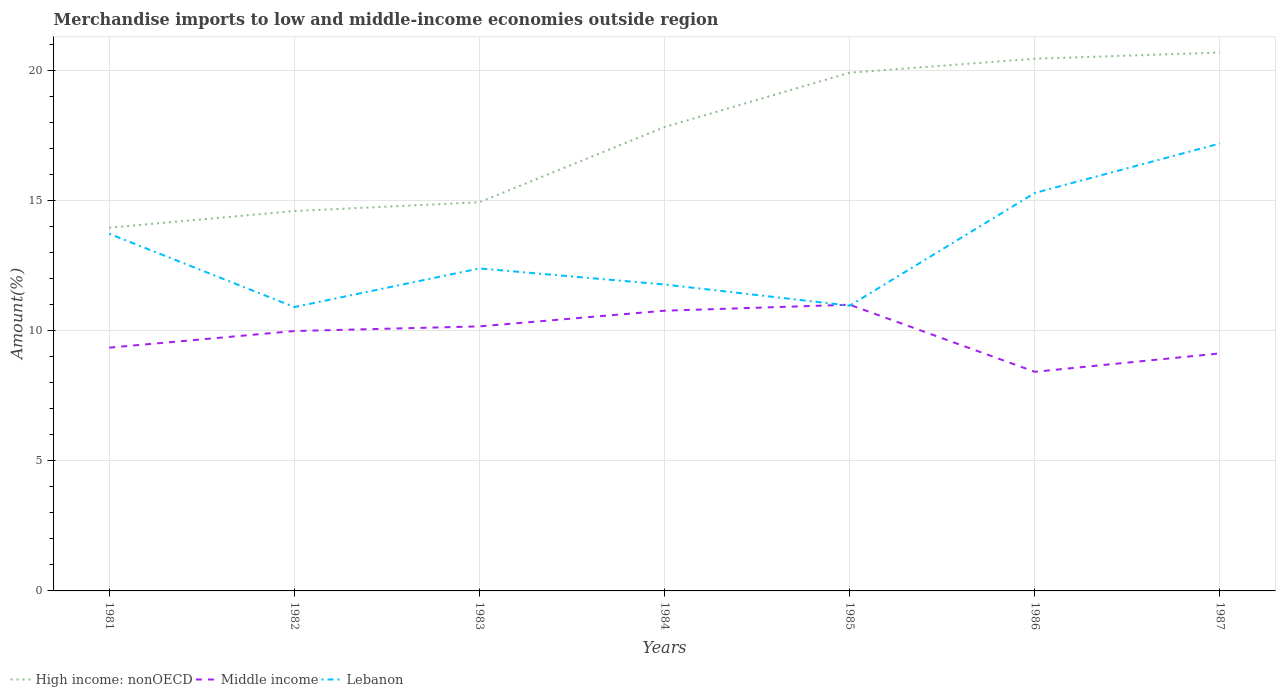Across all years, what is the maximum percentage of amount earned from merchandise imports in Lebanon?
Give a very brief answer. 10.9. In which year was the percentage of amount earned from merchandise imports in Middle income maximum?
Give a very brief answer. 1986. What is the total percentage of amount earned from merchandise imports in Middle income in the graph?
Make the answer very short. 0.86. What is the difference between the highest and the second highest percentage of amount earned from merchandise imports in Lebanon?
Provide a succinct answer. 6.28. How many lines are there?
Your response must be concise. 3. Does the graph contain any zero values?
Provide a short and direct response. No. What is the title of the graph?
Provide a short and direct response. Merchandise imports to low and middle-income economies outside region. What is the label or title of the Y-axis?
Offer a terse response. Amount(%). What is the Amount(%) of High income: nonOECD in 1981?
Offer a very short reply. 13.95. What is the Amount(%) in Middle income in 1981?
Provide a short and direct response. 9.34. What is the Amount(%) of Lebanon in 1981?
Your answer should be compact. 13.71. What is the Amount(%) of High income: nonOECD in 1982?
Your answer should be compact. 14.59. What is the Amount(%) of Middle income in 1982?
Your answer should be compact. 9.98. What is the Amount(%) of Lebanon in 1982?
Keep it short and to the point. 10.9. What is the Amount(%) of High income: nonOECD in 1983?
Offer a terse response. 14.93. What is the Amount(%) in Middle income in 1983?
Your answer should be compact. 10.16. What is the Amount(%) in Lebanon in 1983?
Offer a terse response. 12.38. What is the Amount(%) of High income: nonOECD in 1984?
Offer a terse response. 17.81. What is the Amount(%) of Middle income in 1984?
Ensure brevity in your answer.  10.76. What is the Amount(%) of Lebanon in 1984?
Your answer should be compact. 11.77. What is the Amount(%) in High income: nonOECD in 1985?
Provide a succinct answer. 19.9. What is the Amount(%) in Middle income in 1985?
Give a very brief answer. 10.99. What is the Amount(%) of Lebanon in 1985?
Provide a succinct answer. 10.96. What is the Amount(%) of High income: nonOECD in 1986?
Ensure brevity in your answer.  20.44. What is the Amount(%) in Middle income in 1986?
Your answer should be very brief. 8.41. What is the Amount(%) of Lebanon in 1986?
Provide a succinct answer. 15.28. What is the Amount(%) in High income: nonOECD in 1987?
Your response must be concise. 20.68. What is the Amount(%) in Middle income in 1987?
Offer a terse response. 9.12. What is the Amount(%) of Lebanon in 1987?
Offer a terse response. 17.18. Across all years, what is the maximum Amount(%) of High income: nonOECD?
Your answer should be compact. 20.68. Across all years, what is the maximum Amount(%) of Middle income?
Your answer should be very brief. 10.99. Across all years, what is the maximum Amount(%) in Lebanon?
Offer a terse response. 17.18. Across all years, what is the minimum Amount(%) of High income: nonOECD?
Offer a very short reply. 13.95. Across all years, what is the minimum Amount(%) in Middle income?
Your answer should be compact. 8.41. Across all years, what is the minimum Amount(%) in Lebanon?
Keep it short and to the point. 10.9. What is the total Amount(%) in High income: nonOECD in the graph?
Provide a succinct answer. 122.29. What is the total Amount(%) in Middle income in the graph?
Keep it short and to the point. 68.77. What is the total Amount(%) in Lebanon in the graph?
Your answer should be very brief. 92.19. What is the difference between the Amount(%) of High income: nonOECD in 1981 and that in 1982?
Make the answer very short. -0.64. What is the difference between the Amount(%) of Middle income in 1981 and that in 1982?
Offer a very short reply. -0.64. What is the difference between the Amount(%) of Lebanon in 1981 and that in 1982?
Keep it short and to the point. 2.81. What is the difference between the Amount(%) of High income: nonOECD in 1981 and that in 1983?
Make the answer very short. -0.98. What is the difference between the Amount(%) of Middle income in 1981 and that in 1983?
Your answer should be very brief. -0.82. What is the difference between the Amount(%) in Lebanon in 1981 and that in 1983?
Your response must be concise. 1.33. What is the difference between the Amount(%) in High income: nonOECD in 1981 and that in 1984?
Offer a terse response. -3.86. What is the difference between the Amount(%) of Middle income in 1981 and that in 1984?
Your response must be concise. -1.42. What is the difference between the Amount(%) of Lebanon in 1981 and that in 1984?
Keep it short and to the point. 1.95. What is the difference between the Amount(%) of High income: nonOECD in 1981 and that in 1985?
Provide a short and direct response. -5.95. What is the difference between the Amount(%) in Middle income in 1981 and that in 1985?
Keep it short and to the point. -1.65. What is the difference between the Amount(%) of Lebanon in 1981 and that in 1985?
Give a very brief answer. 2.76. What is the difference between the Amount(%) in High income: nonOECD in 1981 and that in 1986?
Your answer should be very brief. -6.49. What is the difference between the Amount(%) in Middle income in 1981 and that in 1986?
Offer a terse response. 0.93. What is the difference between the Amount(%) of Lebanon in 1981 and that in 1986?
Make the answer very short. -1.57. What is the difference between the Amount(%) of High income: nonOECD in 1981 and that in 1987?
Your answer should be compact. -6.73. What is the difference between the Amount(%) of Middle income in 1981 and that in 1987?
Your response must be concise. 0.22. What is the difference between the Amount(%) in Lebanon in 1981 and that in 1987?
Provide a succinct answer. -3.47. What is the difference between the Amount(%) of High income: nonOECD in 1982 and that in 1983?
Offer a terse response. -0.34. What is the difference between the Amount(%) of Middle income in 1982 and that in 1983?
Offer a terse response. -0.18. What is the difference between the Amount(%) in Lebanon in 1982 and that in 1983?
Provide a succinct answer. -1.48. What is the difference between the Amount(%) in High income: nonOECD in 1982 and that in 1984?
Offer a terse response. -3.23. What is the difference between the Amount(%) in Middle income in 1982 and that in 1984?
Provide a short and direct response. -0.78. What is the difference between the Amount(%) of Lebanon in 1982 and that in 1984?
Your answer should be compact. -0.87. What is the difference between the Amount(%) of High income: nonOECD in 1982 and that in 1985?
Provide a short and direct response. -5.31. What is the difference between the Amount(%) of Middle income in 1982 and that in 1985?
Provide a short and direct response. -1.01. What is the difference between the Amount(%) in Lebanon in 1982 and that in 1985?
Your answer should be compact. -0.05. What is the difference between the Amount(%) of High income: nonOECD in 1982 and that in 1986?
Ensure brevity in your answer.  -5.85. What is the difference between the Amount(%) in Middle income in 1982 and that in 1986?
Keep it short and to the point. 1.57. What is the difference between the Amount(%) in Lebanon in 1982 and that in 1986?
Offer a terse response. -4.38. What is the difference between the Amount(%) of High income: nonOECD in 1982 and that in 1987?
Offer a terse response. -6.09. What is the difference between the Amount(%) in Middle income in 1982 and that in 1987?
Your answer should be compact. 0.86. What is the difference between the Amount(%) of Lebanon in 1982 and that in 1987?
Ensure brevity in your answer.  -6.28. What is the difference between the Amount(%) in High income: nonOECD in 1983 and that in 1984?
Give a very brief answer. -2.89. What is the difference between the Amount(%) in Middle income in 1983 and that in 1984?
Provide a short and direct response. -0.6. What is the difference between the Amount(%) in Lebanon in 1983 and that in 1984?
Ensure brevity in your answer.  0.62. What is the difference between the Amount(%) of High income: nonOECD in 1983 and that in 1985?
Keep it short and to the point. -4.97. What is the difference between the Amount(%) in Middle income in 1983 and that in 1985?
Your answer should be very brief. -0.83. What is the difference between the Amount(%) of Lebanon in 1983 and that in 1985?
Give a very brief answer. 1.43. What is the difference between the Amount(%) in High income: nonOECD in 1983 and that in 1986?
Offer a terse response. -5.51. What is the difference between the Amount(%) of Middle income in 1983 and that in 1986?
Your answer should be compact. 1.74. What is the difference between the Amount(%) of Lebanon in 1983 and that in 1986?
Provide a succinct answer. -2.9. What is the difference between the Amount(%) of High income: nonOECD in 1983 and that in 1987?
Offer a terse response. -5.75. What is the difference between the Amount(%) in Middle income in 1983 and that in 1987?
Make the answer very short. 1.04. What is the difference between the Amount(%) of Lebanon in 1983 and that in 1987?
Provide a short and direct response. -4.8. What is the difference between the Amount(%) of High income: nonOECD in 1984 and that in 1985?
Give a very brief answer. -2.09. What is the difference between the Amount(%) of Middle income in 1984 and that in 1985?
Your answer should be compact. -0.23. What is the difference between the Amount(%) in Lebanon in 1984 and that in 1985?
Your answer should be very brief. 0.81. What is the difference between the Amount(%) in High income: nonOECD in 1984 and that in 1986?
Ensure brevity in your answer.  -2.62. What is the difference between the Amount(%) in Middle income in 1984 and that in 1986?
Ensure brevity in your answer.  2.35. What is the difference between the Amount(%) in Lebanon in 1984 and that in 1986?
Give a very brief answer. -3.52. What is the difference between the Amount(%) of High income: nonOECD in 1984 and that in 1987?
Keep it short and to the point. -2.86. What is the difference between the Amount(%) in Middle income in 1984 and that in 1987?
Offer a terse response. 1.64. What is the difference between the Amount(%) of Lebanon in 1984 and that in 1987?
Offer a terse response. -5.42. What is the difference between the Amount(%) of High income: nonOECD in 1985 and that in 1986?
Offer a terse response. -0.54. What is the difference between the Amount(%) of Middle income in 1985 and that in 1986?
Your answer should be very brief. 2.58. What is the difference between the Amount(%) of Lebanon in 1985 and that in 1986?
Provide a succinct answer. -4.33. What is the difference between the Amount(%) in High income: nonOECD in 1985 and that in 1987?
Provide a short and direct response. -0.77. What is the difference between the Amount(%) of Middle income in 1985 and that in 1987?
Your answer should be very brief. 1.87. What is the difference between the Amount(%) of Lebanon in 1985 and that in 1987?
Offer a very short reply. -6.23. What is the difference between the Amount(%) in High income: nonOECD in 1986 and that in 1987?
Your response must be concise. -0.24. What is the difference between the Amount(%) of Middle income in 1986 and that in 1987?
Your response must be concise. -0.71. What is the difference between the Amount(%) of Lebanon in 1986 and that in 1987?
Your answer should be compact. -1.9. What is the difference between the Amount(%) in High income: nonOECD in 1981 and the Amount(%) in Middle income in 1982?
Offer a very short reply. 3.97. What is the difference between the Amount(%) of High income: nonOECD in 1981 and the Amount(%) of Lebanon in 1982?
Your answer should be compact. 3.05. What is the difference between the Amount(%) in Middle income in 1981 and the Amount(%) in Lebanon in 1982?
Give a very brief answer. -1.56. What is the difference between the Amount(%) of High income: nonOECD in 1981 and the Amount(%) of Middle income in 1983?
Offer a terse response. 3.79. What is the difference between the Amount(%) in High income: nonOECD in 1981 and the Amount(%) in Lebanon in 1983?
Offer a terse response. 1.57. What is the difference between the Amount(%) of Middle income in 1981 and the Amount(%) of Lebanon in 1983?
Your answer should be compact. -3.04. What is the difference between the Amount(%) of High income: nonOECD in 1981 and the Amount(%) of Middle income in 1984?
Give a very brief answer. 3.19. What is the difference between the Amount(%) in High income: nonOECD in 1981 and the Amount(%) in Lebanon in 1984?
Keep it short and to the point. 2.18. What is the difference between the Amount(%) of Middle income in 1981 and the Amount(%) of Lebanon in 1984?
Give a very brief answer. -2.43. What is the difference between the Amount(%) of High income: nonOECD in 1981 and the Amount(%) of Middle income in 1985?
Offer a very short reply. 2.96. What is the difference between the Amount(%) in High income: nonOECD in 1981 and the Amount(%) in Lebanon in 1985?
Provide a succinct answer. 2.99. What is the difference between the Amount(%) of Middle income in 1981 and the Amount(%) of Lebanon in 1985?
Offer a terse response. -1.61. What is the difference between the Amount(%) in High income: nonOECD in 1981 and the Amount(%) in Middle income in 1986?
Your response must be concise. 5.53. What is the difference between the Amount(%) of High income: nonOECD in 1981 and the Amount(%) of Lebanon in 1986?
Provide a short and direct response. -1.33. What is the difference between the Amount(%) in Middle income in 1981 and the Amount(%) in Lebanon in 1986?
Make the answer very short. -5.94. What is the difference between the Amount(%) in High income: nonOECD in 1981 and the Amount(%) in Middle income in 1987?
Ensure brevity in your answer.  4.83. What is the difference between the Amount(%) in High income: nonOECD in 1981 and the Amount(%) in Lebanon in 1987?
Offer a very short reply. -3.23. What is the difference between the Amount(%) in Middle income in 1981 and the Amount(%) in Lebanon in 1987?
Make the answer very short. -7.84. What is the difference between the Amount(%) in High income: nonOECD in 1982 and the Amount(%) in Middle income in 1983?
Your answer should be very brief. 4.43. What is the difference between the Amount(%) in High income: nonOECD in 1982 and the Amount(%) in Lebanon in 1983?
Offer a terse response. 2.2. What is the difference between the Amount(%) in Middle income in 1982 and the Amount(%) in Lebanon in 1983?
Your answer should be compact. -2.4. What is the difference between the Amount(%) of High income: nonOECD in 1982 and the Amount(%) of Middle income in 1984?
Provide a succinct answer. 3.83. What is the difference between the Amount(%) in High income: nonOECD in 1982 and the Amount(%) in Lebanon in 1984?
Offer a terse response. 2.82. What is the difference between the Amount(%) in Middle income in 1982 and the Amount(%) in Lebanon in 1984?
Offer a terse response. -1.79. What is the difference between the Amount(%) in High income: nonOECD in 1982 and the Amount(%) in Middle income in 1985?
Offer a very short reply. 3.6. What is the difference between the Amount(%) of High income: nonOECD in 1982 and the Amount(%) of Lebanon in 1985?
Give a very brief answer. 3.63. What is the difference between the Amount(%) of Middle income in 1982 and the Amount(%) of Lebanon in 1985?
Your response must be concise. -0.97. What is the difference between the Amount(%) of High income: nonOECD in 1982 and the Amount(%) of Middle income in 1986?
Keep it short and to the point. 6.17. What is the difference between the Amount(%) in High income: nonOECD in 1982 and the Amount(%) in Lebanon in 1986?
Your response must be concise. -0.69. What is the difference between the Amount(%) in Middle income in 1982 and the Amount(%) in Lebanon in 1986?
Keep it short and to the point. -5.3. What is the difference between the Amount(%) in High income: nonOECD in 1982 and the Amount(%) in Middle income in 1987?
Your answer should be very brief. 5.47. What is the difference between the Amount(%) of High income: nonOECD in 1982 and the Amount(%) of Lebanon in 1987?
Offer a very short reply. -2.59. What is the difference between the Amount(%) in Middle income in 1982 and the Amount(%) in Lebanon in 1987?
Your answer should be very brief. -7.2. What is the difference between the Amount(%) in High income: nonOECD in 1983 and the Amount(%) in Middle income in 1984?
Offer a terse response. 4.17. What is the difference between the Amount(%) of High income: nonOECD in 1983 and the Amount(%) of Lebanon in 1984?
Offer a very short reply. 3.16. What is the difference between the Amount(%) of Middle income in 1983 and the Amount(%) of Lebanon in 1984?
Make the answer very short. -1.61. What is the difference between the Amount(%) of High income: nonOECD in 1983 and the Amount(%) of Middle income in 1985?
Make the answer very short. 3.94. What is the difference between the Amount(%) in High income: nonOECD in 1983 and the Amount(%) in Lebanon in 1985?
Provide a succinct answer. 3.97. What is the difference between the Amount(%) of Middle income in 1983 and the Amount(%) of Lebanon in 1985?
Offer a very short reply. -0.8. What is the difference between the Amount(%) of High income: nonOECD in 1983 and the Amount(%) of Middle income in 1986?
Offer a very short reply. 6.51. What is the difference between the Amount(%) in High income: nonOECD in 1983 and the Amount(%) in Lebanon in 1986?
Offer a very short reply. -0.36. What is the difference between the Amount(%) in Middle income in 1983 and the Amount(%) in Lebanon in 1986?
Offer a very short reply. -5.12. What is the difference between the Amount(%) of High income: nonOECD in 1983 and the Amount(%) of Middle income in 1987?
Give a very brief answer. 5.81. What is the difference between the Amount(%) in High income: nonOECD in 1983 and the Amount(%) in Lebanon in 1987?
Make the answer very short. -2.26. What is the difference between the Amount(%) of Middle income in 1983 and the Amount(%) of Lebanon in 1987?
Ensure brevity in your answer.  -7.02. What is the difference between the Amount(%) of High income: nonOECD in 1984 and the Amount(%) of Middle income in 1985?
Your answer should be very brief. 6.82. What is the difference between the Amount(%) in High income: nonOECD in 1984 and the Amount(%) in Lebanon in 1985?
Your answer should be very brief. 6.86. What is the difference between the Amount(%) in Middle income in 1984 and the Amount(%) in Lebanon in 1985?
Offer a very short reply. -0.19. What is the difference between the Amount(%) of High income: nonOECD in 1984 and the Amount(%) of Middle income in 1986?
Offer a terse response. 9.4. What is the difference between the Amount(%) of High income: nonOECD in 1984 and the Amount(%) of Lebanon in 1986?
Your answer should be compact. 2.53. What is the difference between the Amount(%) in Middle income in 1984 and the Amount(%) in Lebanon in 1986?
Provide a short and direct response. -4.52. What is the difference between the Amount(%) of High income: nonOECD in 1984 and the Amount(%) of Middle income in 1987?
Make the answer very short. 8.69. What is the difference between the Amount(%) in High income: nonOECD in 1984 and the Amount(%) in Lebanon in 1987?
Your response must be concise. 0.63. What is the difference between the Amount(%) in Middle income in 1984 and the Amount(%) in Lebanon in 1987?
Provide a short and direct response. -6.42. What is the difference between the Amount(%) of High income: nonOECD in 1985 and the Amount(%) of Middle income in 1986?
Provide a succinct answer. 11.49. What is the difference between the Amount(%) in High income: nonOECD in 1985 and the Amount(%) in Lebanon in 1986?
Your answer should be very brief. 4.62. What is the difference between the Amount(%) in Middle income in 1985 and the Amount(%) in Lebanon in 1986?
Provide a succinct answer. -4.29. What is the difference between the Amount(%) of High income: nonOECD in 1985 and the Amount(%) of Middle income in 1987?
Your answer should be compact. 10.78. What is the difference between the Amount(%) in High income: nonOECD in 1985 and the Amount(%) in Lebanon in 1987?
Offer a terse response. 2.72. What is the difference between the Amount(%) in Middle income in 1985 and the Amount(%) in Lebanon in 1987?
Your answer should be very brief. -6.19. What is the difference between the Amount(%) in High income: nonOECD in 1986 and the Amount(%) in Middle income in 1987?
Offer a terse response. 11.32. What is the difference between the Amount(%) in High income: nonOECD in 1986 and the Amount(%) in Lebanon in 1987?
Make the answer very short. 3.25. What is the difference between the Amount(%) in Middle income in 1986 and the Amount(%) in Lebanon in 1987?
Ensure brevity in your answer.  -8.77. What is the average Amount(%) of High income: nonOECD per year?
Your response must be concise. 17.47. What is the average Amount(%) of Middle income per year?
Your answer should be very brief. 9.82. What is the average Amount(%) of Lebanon per year?
Provide a succinct answer. 13.17. In the year 1981, what is the difference between the Amount(%) of High income: nonOECD and Amount(%) of Middle income?
Your response must be concise. 4.61. In the year 1981, what is the difference between the Amount(%) in High income: nonOECD and Amount(%) in Lebanon?
Provide a short and direct response. 0.23. In the year 1981, what is the difference between the Amount(%) in Middle income and Amount(%) in Lebanon?
Your answer should be compact. -4.37. In the year 1982, what is the difference between the Amount(%) in High income: nonOECD and Amount(%) in Middle income?
Provide a short and direct response. 4.61. In the year 1982, what is the difference between the Amount(%) of High income: nonOECD and Amount(%) of Lebanon?
Provide a short and direct response. 3.69. In the year 1982, what is the difference between the Amount(%) of Middle income and Amount(%) of Lebanon?
Keep it short and to the point. -0.92. In the year 1983, what is the difference between the Amount(%) of High income: nonOECD and Amount(%) of Middle income?
Offer a terse response. 4.77. In the year 1983, what is the difference between the Amount(%) in High income: nonOECD and Amount(%) in Lebanon?
Keep it short and to the point. 2.54. In the year 1983, what is the difference between the Amount(%) of Middle income and Amount(%) of Lebanon?
Make the answer very short. -2.22. In the year 1984, what is the difference between the Amount(%) in High income: nonOECD and Amount(%) in Middle income?
Ensure brevity in your answer.  7.05. In the year 1984, what is the difference between the Amount(%) of High income: nonOECD and Amount(%) of Lebanon?
Ensure brevity in your answer.  6.05. In the year 1984, what is the difference between the Amount(%) of Middle income and Amount(%) of Lebanon?
Make the answer very short. -1.01. In the year 1985, what is the difference between the Amount(%) of High income: nonOECD and Amount(%) of Middle income?
Your response must be concise. 8.91. In the year 1985, what is the difference between the Amount(%) in High income: nonOECD and Amount(%) in Lebanon?
Provide a short and direct response. 8.95. In the year 1985, what is the difference between the Amount(%) in Middle income and Amount(%) in Lebanon?
Your answer should be compact. 0.03. In the year 1986, what is the difference between the Amount(%) in High income: nonOECD and Amount(%) in Middle income?
Your answer should be very brief. 12.02. In the year 1986, what is the difference between the Amount(%) in High income: nonOECD and Amount(%) in Lebanon?
Offer a terse response. 5.15. In the year 1986, what is the difference between the Amount(%) of Middle income and Amount(%) of Lebanon?
Offer a very short reply. -6.87. In the year 1987, what is the difference between the Amount(%) of High income: nonOECD and Amount(%) of Middle income?
Your response must be concise. 11.55. In the year 1987, what is the difference between the Amount(%) in High income: nonOECD and Amount(%) in Lebanon?
Make the answer very short. 3.49. In the year 1987, what is the difference between the Amount(%) in Middle income and Amount(%) in Lebanon?
Your answer should be very brief. -8.06. What is the ratio of the Amount(%) in High income: nonOECD in 1981 to that in 1982?
Offer a very short reply. 0.96. What is the ratio of the Amount(%) in Middle income in 1981 to that in 1982?
Provide a succinct answer. 0.94. What is the ratio of the Amount(%) in Lebanon in 1981 to that in 1982?
Give a very brief answer. 1.26. What is the ratio of the Amount(%) of High income: nonOECD in 1981 to that in 1983?
Give a very brief answer. 0.93. What is the ratio of the Amount(%) in Middle income in 1981 to that in 1983?
Ensure brevity in your answer.  0.92. What is the ratio of the Amount(%) of Lebanon in 1981 to that in 1983?
Provide a short and direct response. 1.11. What is the ratio of the Amount(%) of High income: nonOECD in 1981 to that in 1984?
Make the answer very short. 0.78. What is the ratio of the Amount(%) in Middle income in 1981 to that in 1984?
Provide a succinct answer. 0.87. What is the ratio of the Amount(%) in Lebanon in 1981 to that in 1984?
Make the answer very short. 1.17. What is the ratio of the Amount(%) of High income: nonOECD in 1981 to that in 1985?
Make the answer very short. 0.7. What is the ratio of the Amount(%) of Middle income in 1981 to that in 1985?
Your answer should be compact. 0.85. What is the ratio of the Amount(%) of Lebanon in 1981 to that in 1985?
Your answer should be very brief. 1.25. What is the ratio of the Amount(%) of High income: nonOECD in 1981 to that in 1986?
Your answer should be compact. 0.68. What is the ratio of the Amount(%) of Middle income in 1981 to that in 1986?
Provide a short and direct response. 1.11. What is the ratio of the Amount(%) of Lebanon in 1981 to that in 1986?
Your answer should be very brief. 0.9. What is the ratio of the Amount(%) of High income: nonOECD in 1981 to that in 1987?
Offer a very short reply. 0.67. What is the ratio of the Amount(%) in Middle income in 1981 to that in 1987?
Offer a terse response. 1.02. What is the ratio of the Amount(%) of Lebanon in 1981 to that in 1987?
Make the answer very short. 0.8. What is the ratio of the Amount(%) in High income: nonOECD in 1982 to that in 1983?
Your answer should be compact. 0.98. What is the ratio of the Amount(%) in Middle income in 1982 to that in 1983?
Provide a succinct answer. 0.98. What is the ratio of the Amount(%) in Lebanon in 1982 to that in 1983?
Offer a terse response. 0.88. What is the ratio of the Amount(%) of High income: nonOECD in 1982 to that in 1984?
Offer a terse response. 0.82. What is the ratio of the Amount(%) in Middle income in 1982 to that in 1984?
Your answer should be very brief. 0.93. What is the ratio of the Amount(%) of Lebanon in 1982 to that in 1984?
Your answer should be compact. 0.93. What is the ratio of the Amount(%) of High income: nonOECD in 1982 to that in 1985?
Your response must be concise. 0.73. What is the ratio of the Amount(%) in Middle income in 1982 to that in 1985?
Provide a succinct answer. 0.91. What is the ratio of the Amount(%) in Lebanon in 1982 to that in 1985?
Your response must be concise. 1. What is the ratio of the Amount(%) in High income: nonOECD in 1982 to that in 1986?
Your answer should be compact. 0.71. What is the ratio of the Amount(%) of Middle income in 1982 to that in 1986?
Offer a terse response. 1.19. What is the ratio of the Amount(%) of Lebanon in 1982 to that in 1986?
Offer a very short reply. 0.71. What is the ratio of the Amount(%) in High income: nonOECD in 1982 to that in 1987?
Ensure brevity in your answer.  0.71. What is the ratio of the Amount(%) of Middle income in 1982 to that in 1987?
Make the answer very short. 1.09. What is the ratio of the Amount(%) of Lebanon in 1982 to that in 1987?
Offer a very short reply. 0.63. What is the ratio of the Amount(%) in High income: nonOECD in 1983 to that in 1984?
Ensure brevity in your answer.  0.84. What is the ratio of the Amount(%) in Middle income in 1983 to that in 1984?
Your answer should be compact. 0.94. What is the ratio of the Amount(%) in Lebanon in 1983 to that in 1984?
Your answer should be very brief. 1.05. What is the ratio of the Amount(%) of High income: nonOECD in 1983 to that in 1985?
Make the answer very short. 0.75. What is the ratio of the Amount(%) in Middle income in 1983 to that in 1985?
Your response must be concise. 0.92. What is the ratio of the Amount(%) of Lebanon in 1983 to that in 1985?
Offer a very short reply. 1.13. What is the ratio of the Amount(%) of High income: nonOECD in 1983 to that in 1986?
Ensure brevity in your answer.  0.73. What is the ratio of the Amount(%) of Middle income in 1983 to that in 1986?
Keep it short and to the point. 1.21. What is the ratio of the Amount(%) in Lebanon in 1983 to that in 1986?
Your answer should be compact. 0.81. What is the ratio of the Amount(%) of High income: nonOECD in 1983 to that in 1987?
Your answer should be very brief. 0.72. What is the ratio of the Amount(%) in Middle income in 1983 to that in 1987?
Ensure brevity in your answer.  1.11. What is the ratio of the Amount(%) of Lebanon in 1983 to that in 1987?
Ensure brevity in your answer.  0.72. What is the ratio of the Amount(%) in High income: nonOECD in 1984 to that in 1985?
Your answer should be compact. 0.9. What is the ratio of the Amount(%) in Middle income in 1984 to that in 1985?
Provide a succinct answer. 0.98. What is the ratio of the Amount(%) in Lebanon in 1984 to that in 1985?
Offer a terse response. 1.07. What is the ratio of the Amount(%) in High income: nonOECD in 1984 to that in 1986?
Make the answer very short. 0.87. What is the ratio of the Amount(%) in Middle income in 1984 to that in 1986?
Ensure brevity in your answer.  1.28. What is the ratio of the Amount(%) of Lebanon in 1984 to that in 1986?
Your response must be concise. 0.77. What is the ratio of the Amount(%) of High income: nonOECD in 1984 to that in 1987?
Offer a very short reply. 0.86. What is the ratio of the Amount(%) in Middle income in 1984 to that in 1987?
Keep it short and to the point. 1.18. What is the ratio of the Amount(%) in Lebanon in 1984 to that in 1987?
Your response must be concise. 0.68. What is the ratio of the Amount(%) of High income: nonOECD in 1985 to that in 1986?
Offer a terse response. 0.97. What is the ratio of the Amount(%) of Middle income in 1985 to that in 1986?
Offer a very short reply. 1.31. What is the ratio of the Amount(%) in Lebanon in 1985 to that in 1986?
Offer a terse response. 0.72. What is the ratio of the Amount(%) of High income: nonOECD in 1985 to that in 1987?
Your answer should be compact. 0.96. What is the ratio of the Amount(%) in Middle income in 1985 to that in 1987?
Keep it short and to the point. 1.2. What is the ratio of the Amount(%) in Lebanon in 1985 to that in 1987?
Make the answer very short. 0.64. What is the ratio of the Amount(%) of High income: nonOECD in 1986 to that in 1987?
Offer a very short reply. 0.99. What is the ratio of the Amount(%) in Middle income in 1986 to that in 1987?
Your response must be concise. 0.92. What is the ratio of the Amount(%) in Lebanon in 1986 to that in 1987?
Provide a succinct answer. 0.89. What is the difference between the highest and the second highest Amount(%) of High income: nonOECD?
Make the answer very short. 0.24. What is the difference between the highest and the second highest Amount(%) in Middle income?
Give a very brief answer. 0.23. What is the difference between the highest and the second highest Amount(%) in Lebanon?
Keep it short and to the point. 1.9. What is the difference between the highest and the lowest Amount(%) of High income: nonOECD?
Give a very brief answer. 6.73. What is the difference between the highest and the lowest Amount(%) of Middle income?
Your answer should be very brief. 2.58. What is the difference between the highest and the lowest Amount(%) of Lebanon?
Keep it short and to the point. 6.28. 